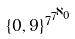<formula> <loc_0><loc_0><loc_500><loc_500>\{ 0 , 9 \} ^ { 7 ^ { 7 ^ { \aleph _ { 0 } } } }</formula> 